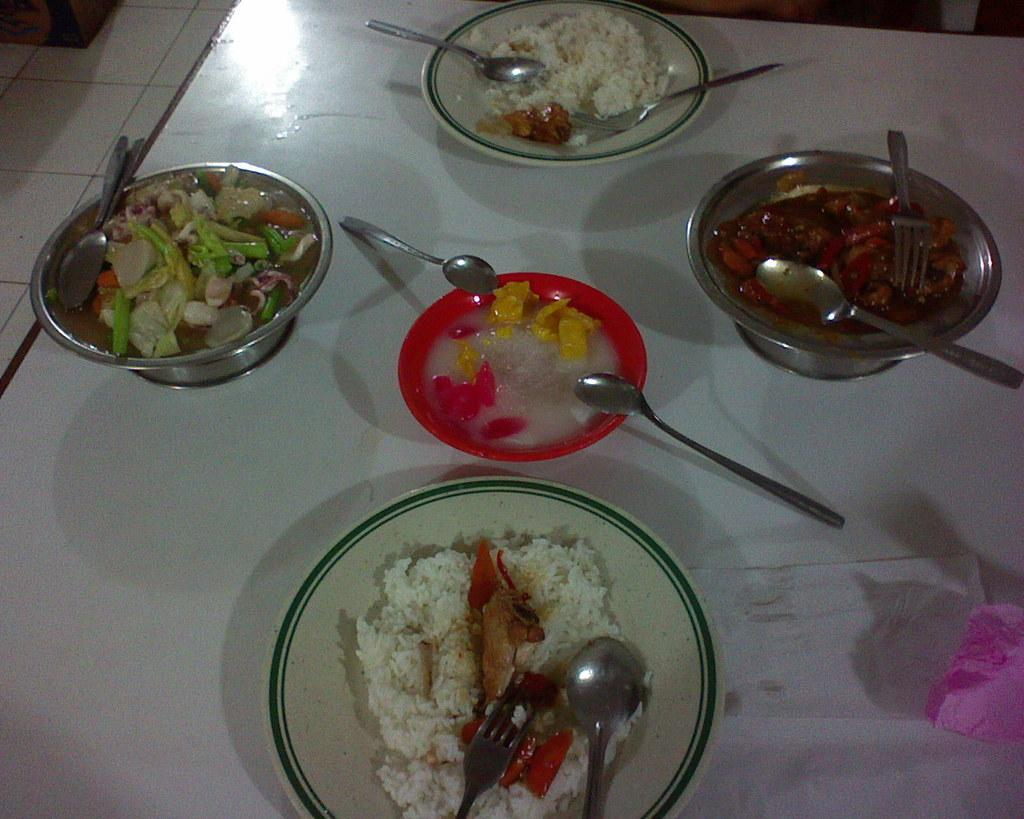What type of furniture is in the center of the image? There is a dining table in the center of the image. What is the purpose of the dining table? The dining table is used for serving and eating food. What items can be seen on the dining table? There are bowls and spoons on the dining table. What is inside the bowls and on the spoons? The bowls and spoons contain food items. How many cats are sitting on the dining table in the image? There are no cats present in the image; it only shows bowls and spoons containing food items. 